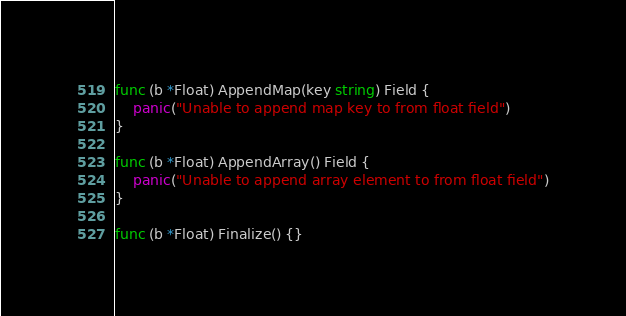<code> <loc_0><loc_0><loc_500><loc_500><_Go_>
func (b *Float) AppendMap(key string) Field {
	panic("Unable to append map key to from float field")
}

func (b *Float) AppendArray() Field {
	panic("Unable to append array element to from float field")
}

func (b *Float) Finalize() {}
</code> 